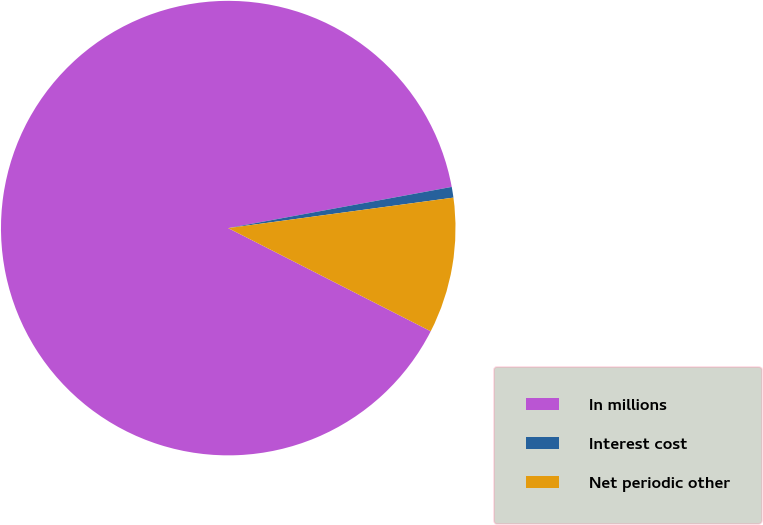<chart> <loc_0><loc_0><loc_500><loc_500><pie_chart><fcel>In millions<fcel>Interest cost<fcel>Net periodic other<nl><fcel>89.6%<fcel>0.76%<fcel>9.64%<nl></chart> 